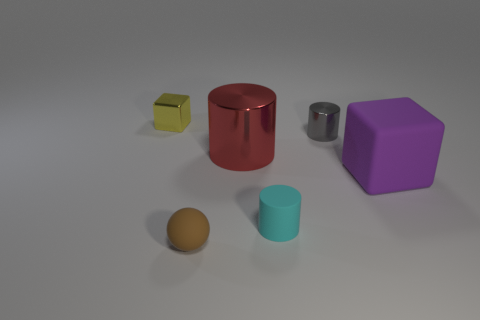Do the block in front of the yellow shiny thing and the red cylinder have the same material?
Make the answer very short. No. What is the material of the tiny object that is on the left side of the large shiny cylinder and behind the brown thing?
Keep it short and to the point. Metal. There is a big object to the left of the small metallic object that is right of the small metal cube; what is its color?
Ensure brevity in your answer.  Red. There is a tiny cyan object that is the same shape as the red shiny thing; what is its material?
Give a very brief answer. Rubber. There is a metallic cylinder left of the small cylinder to the left of the small shiny thing in front of the small yellow metallic cube; what color is it?
Offer a terse response. Red. How many things are metal cylinders or blocks?
Provide a succinct answer. 4. What number of small brown rubber objects are the same shape as the small cyan matte thing?
Offer a very short reply. 0. Does the yellow object have the same material as the cylinder that is in front of the red thing?
Ensure brevity in your answer.  No. There is a cylinder that is made of the same material as the brown thing; what size is it?
Ensure brevity in your answer.  Small. There is a shiny object behind the small shiny cylinder; what size is it?
Make the answer very short. Small. 